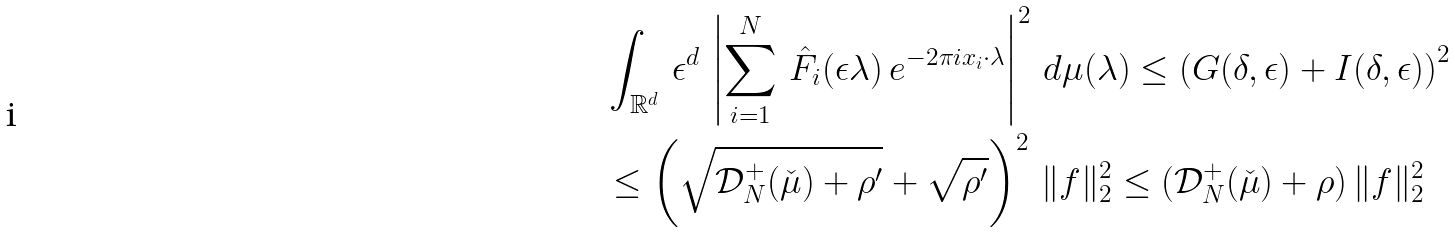<formula> <loc_0><loc_0><loc_500><loc_500>& \int _ { \mathbb { R } ^ { d } } \, \epsilon ^ { d } \, \left | \sum _ { i = 1 } ^ { N } \, \hat { F _ { i } } ( \epsilon \lambda ) \, e ^ { - 2 \pi i x _ { i } \cdot \lambda } \right | ^ { 2 } \, d \mu ( \lambda ) \leq \left ( G ( \delta , \epsilon ) + I ( \delta , \epsilon ) \right ) ^ { 2 } \\ & \leq \left ( \sqrt { \mathcal { D } ^ { + } _ { N } ( \check { \mu } ) + \rho ^ { \prime } } + \sqrt { \rho ^ { \prime } } \right ) ^ { 2 } \, \| f \| _ { 2 } ^ { 2 } \leq ( \mathcal { D } ^ { + } _ { N } ( \check { \mu } ) + \rho ) \, \| f \| _ { 2 } ^ { 2 }</formula> 